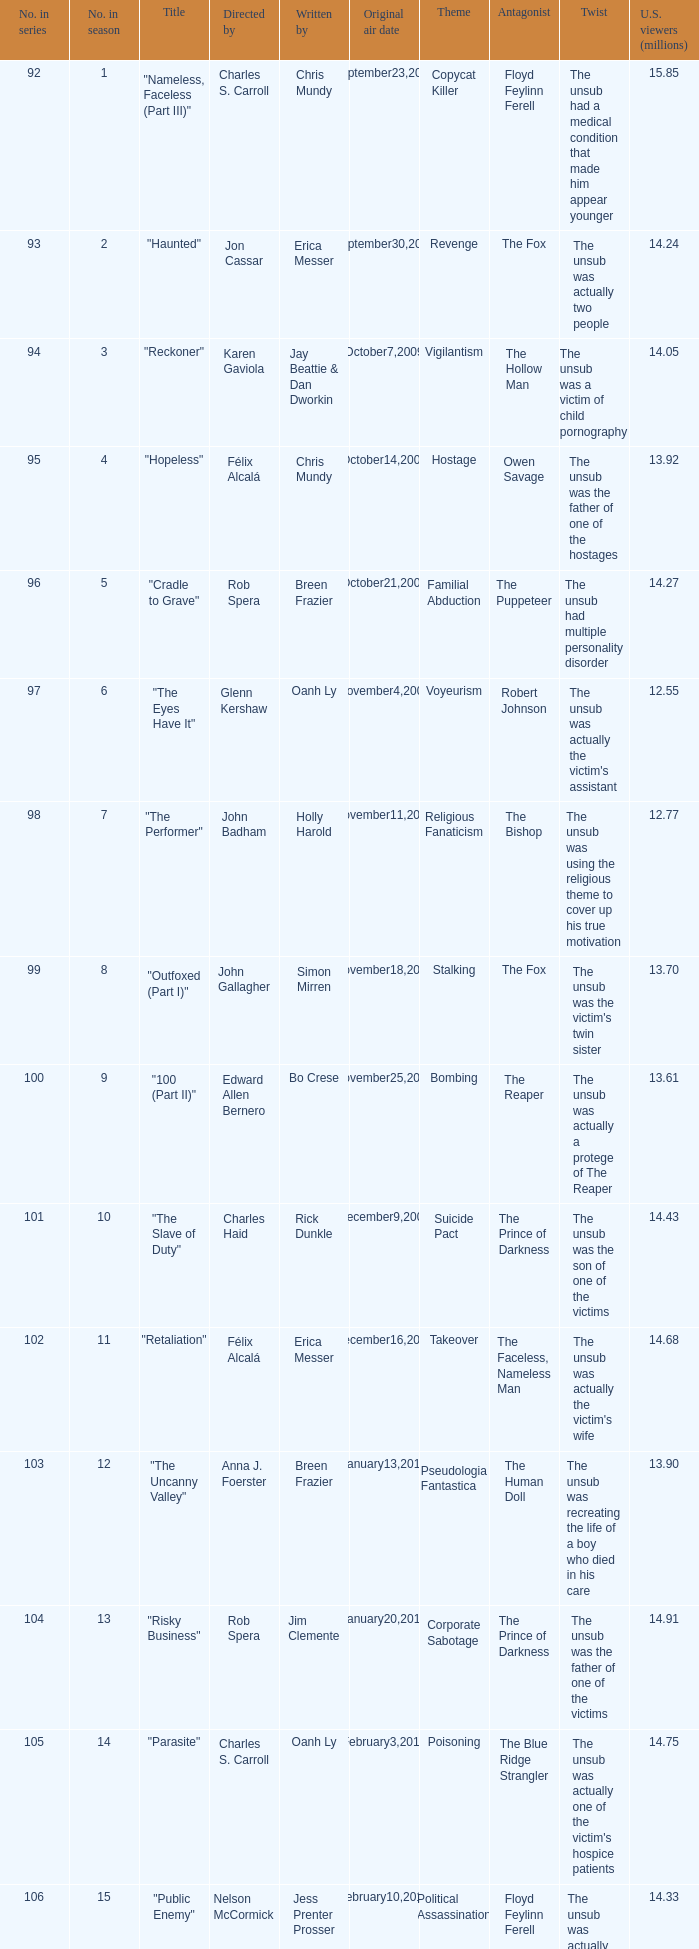What season was the episode "haunted" in? 2.0. 